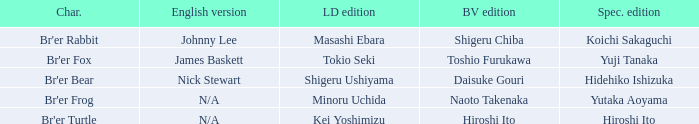What is the special edition where the english version is nick stewart? Hidehiko Ishizuka. 